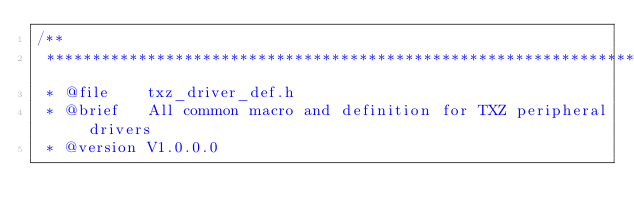Convert code to text. <code><loc_0><loc_0><loc_500><loc_500><_C_>/**
 *******************************************************************************
 * @file    txz_driver_def.h
 * @brief   All common macro and definition for TXZ peripheral drivers
 * @version V1.0.0.0</code> 